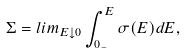Convert formula to latex. <formula><loc_0><loc_0><loc_500><loc_500>\Sigma = l i m _ { E \downarrow 0 } \int _ { 0 _ { - } } ^ { E } \sigma ( E ) d E ,</formula> 